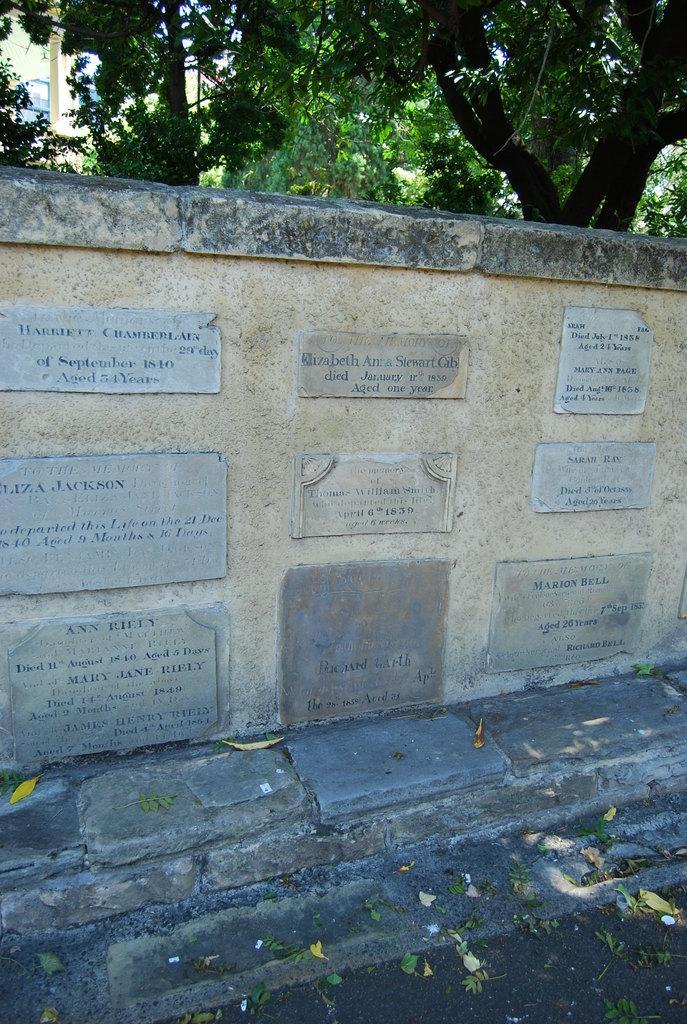Please provide a concise description of this image. These are the memorial stones, which are attached to the wall. These are the trees with branches and leaves. 